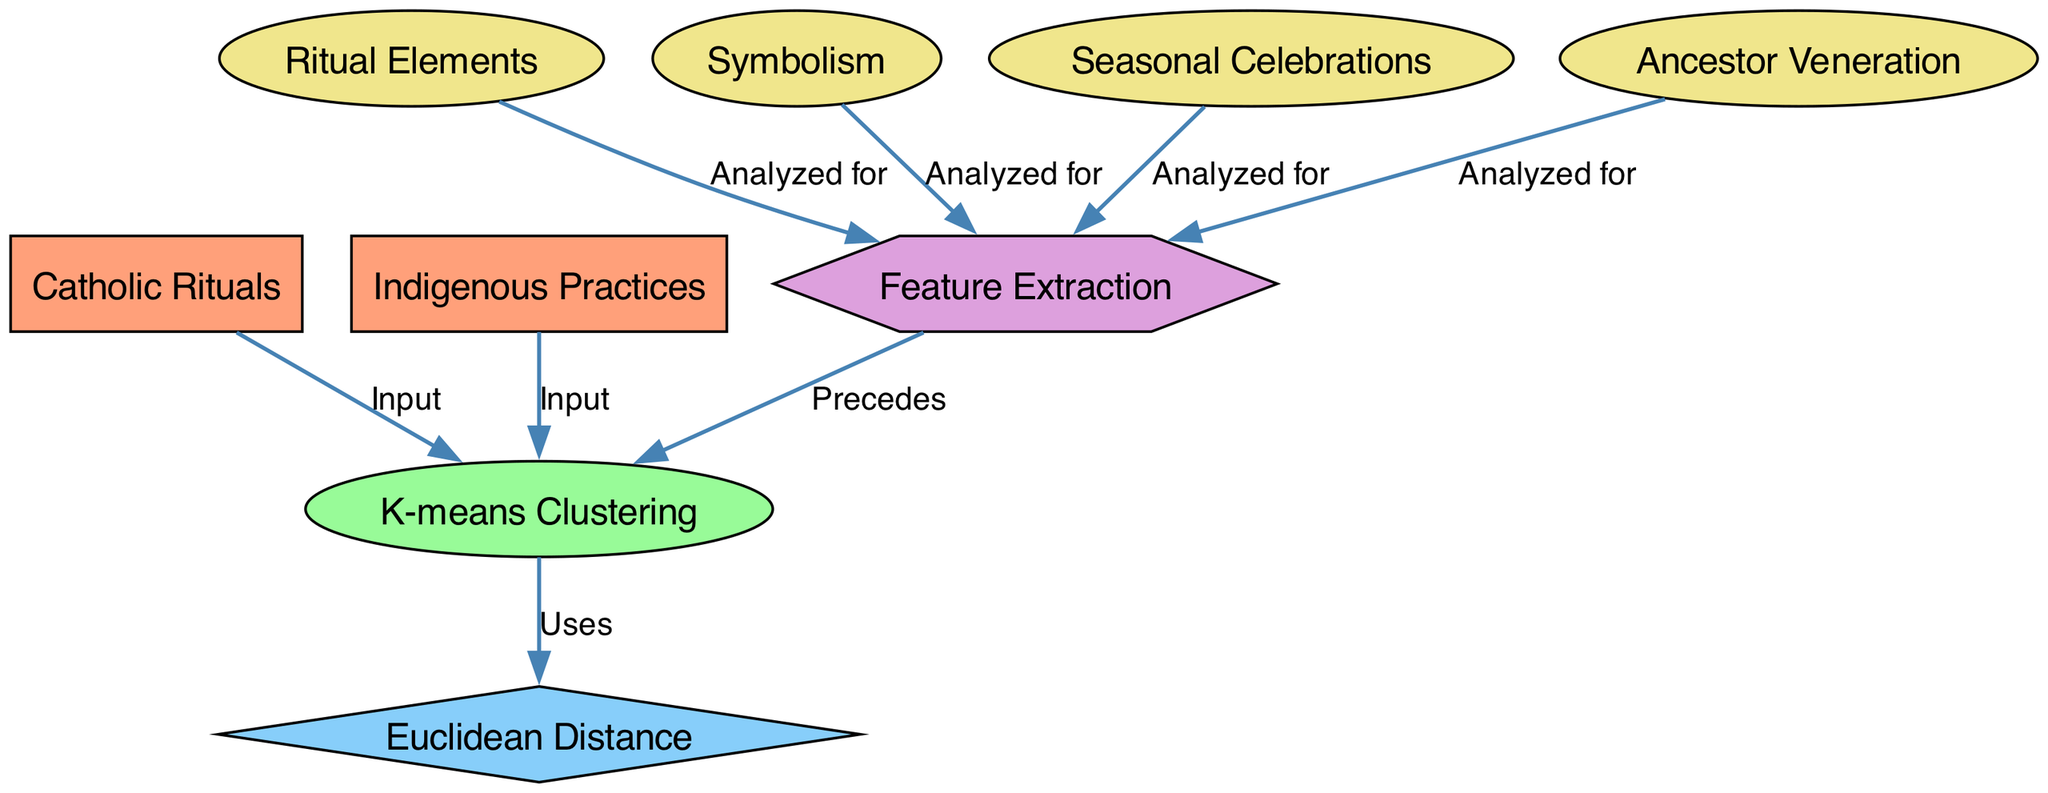What are the two main categories represented in the diagram? The diagram has two main categories labeled "Catholic Rituals" and "Indigenous Practices", represented as two distinct nodes.
Answer: Catholic Rituals, Indigenous Practices How many nodes are present in the diagram? By counting the individual nodes listed (1 for Catholic Rituals, 1 for Indigenous Practices, 1 for K-means Clustering, etc.), there are a total of 9 nodes in the diagram.
Answer: 9 Which node is the output of the K-means Clustering process? The diagram does not specify an output directly after K-means Clustering, but it indicates that it utilizes the "Euclidean Distance" as part of its process, which can often represent the output in clustering scenarios.
Answer: Euclidean Distance What element precedes K-means Clustering in this diagram? The diagram shows that "Feature Extraction" is the node that precedes "K-means Clustering" based on the directed edge labeled "Precedes".
Answer: Feature Extraction How many analyzed elements are listed under Feature Extraction? The diagram includes four analyzed elements that feed into the "Feature Extraction" node: "Ritual Elements", "Symbolism", "Seasonal Celebrations", and "Ancestor Veneration", so there are four elements.
Answer: 4 Which two nodes provide input to K-means Clustering? The diagram indicates that both "Catholic Rituals" and "Indigenous Practices" input directly into the "K-means Clustering" node, as evidenced by the directed edges labeled "Input".
Answer: Catholic Rituals, Indigenous Practices What is the shape of the K-means Clustering node? The diagram specifies that the "K-means Clustering" node is represented as an oval shape, which is indicated in its node definition styling.
Answer: Oval What does the Euclidean Distance node represent in this clustering process? In this diagram, the "Euclidean Distance" node represents a method used by the K-means Clustering process, indicated by the directed edge labeled "Uses", which shows its application in computing distances for clustering.
Answer: Method for distance calculation How are the indigenous practices related to the clustering process? The indigenous practices, represented by their node, serve as one of the main inputs for the clustering process along with Catholic rituals, thus indicating their integration in analyzing similarities.
Answer: Inputs for clustering 